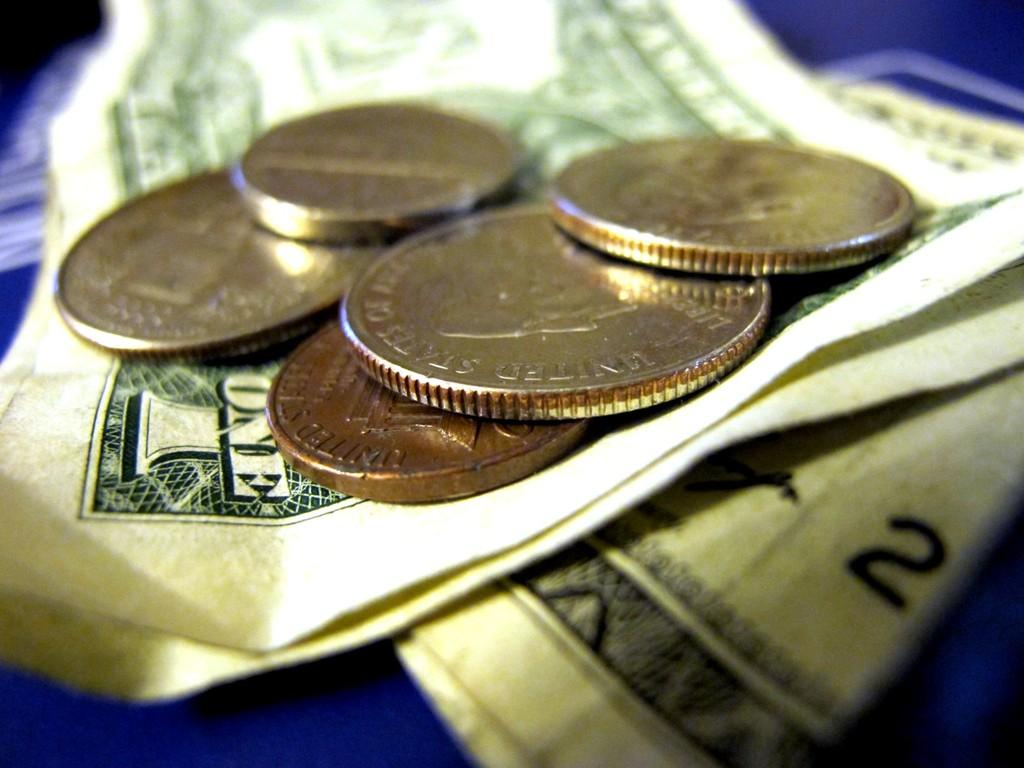Provide a one-sentence caption for the provided image. Five coins on top of three one dollar bills. 